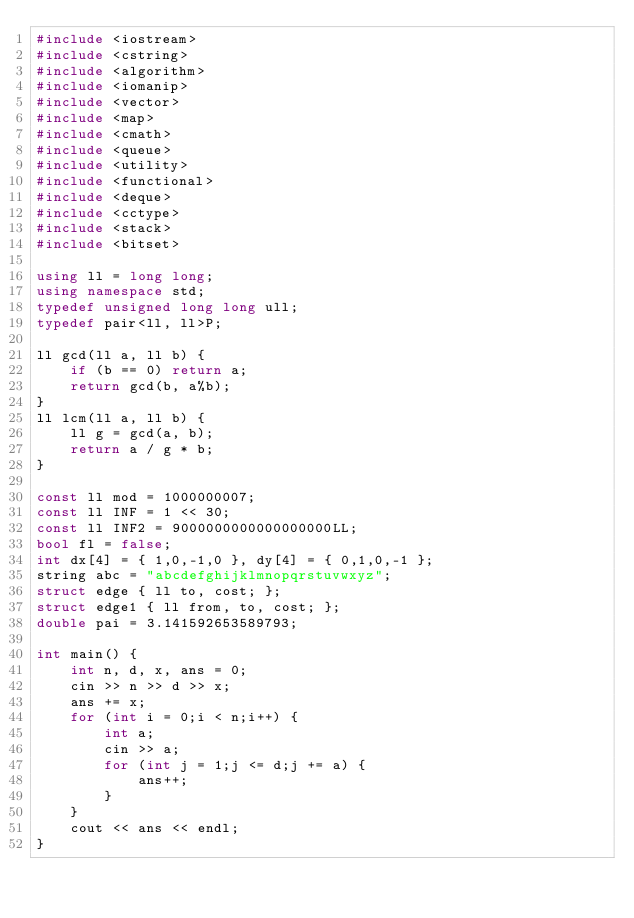<code> <loc_0><loc_0><loc_500><loc_500><_C++_>#include <iostream>
#include <cstring>
#include <algorithm>
#include <iomanip>
#include <vector>
#include <map>
#include <cmath>
#include <queue>
#include <utility>
#include <functional>
#include <deque>
#include <cctype>
#include <stack>
#include <bitset>

using ll = long long;
using namespace std;
typedef unsigned long long ull;
typedef pair<ll, ll>P;

ll gcd(ll a, ll b) {
	if (b == 0) return a;
	return gcd(b, a%b);
}
ll lcm(ll a, ll b) {
	ll g = gcd(a, b);
	return a / g * b;
}

const ll mod = 1000000007;
const ll INF = 1 << 30;
const ll INF2 = 9000000000000000000LL;
bool fl = false;
int dx[4] = { 1,0,-1,0 }, dy[4] = { 0,1,0,-1 };
string abc = "abcdefghijklmnopqrstuvwxyz";
struct edge { ll to, cost; };
struct edge1 { ll from, to, cost; };
double pai = 3.141592653589793;

int main() {
	int n, d, x, ans = 0;
	cin >> n >> d >> x;
	ans += x;
	for (int i = 0;i < n;i++) {
		int a;
		cin >> a;
		for (int j = 1;j <= d;j += a) {
			ans++;
		}
	}
	cout << ans << endl;
}</code> 